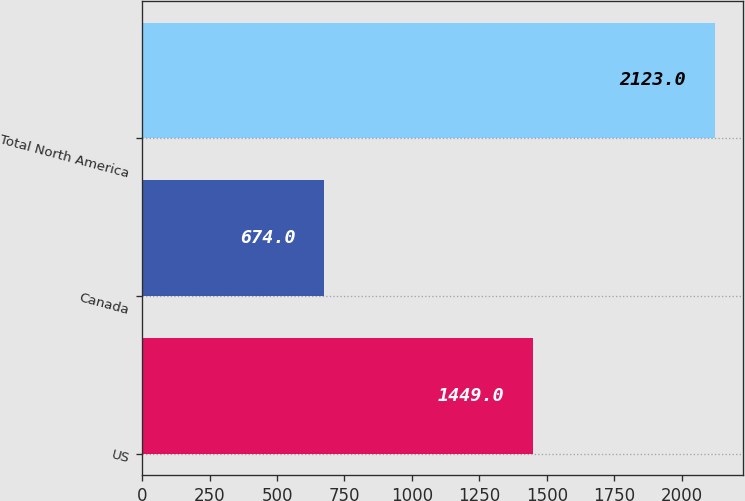Convert chart. <chart><loc_0><loc_0><loc_500><loc_500><bar_chart><fcel>US<fcel>Canada<fcel>Total North America<nl><fcel>1449<fcel>674<fcel>2123<nl></chart> 